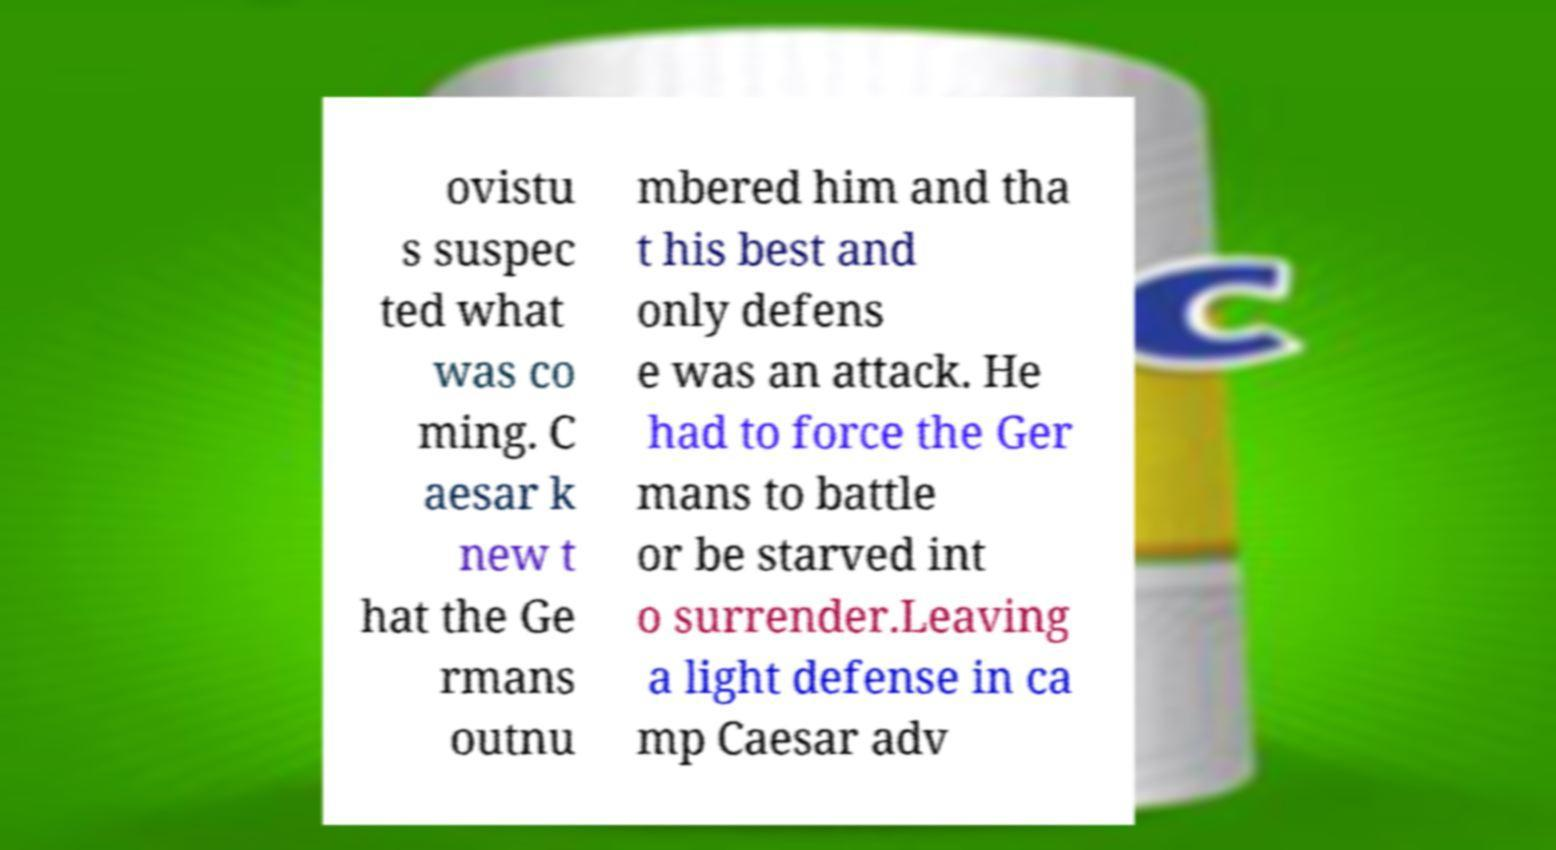Can you accurately transcribe the text from the provided image for me? ovistu s suspec ted what was co ming. C aesar k new t hat the Ge rmans outnu mbered him and tha t his best and only defens e was an attack. He had to force the Ger mans to battle or be starved int o surrender.Leaving a light defense in ca mp Caesar adv 